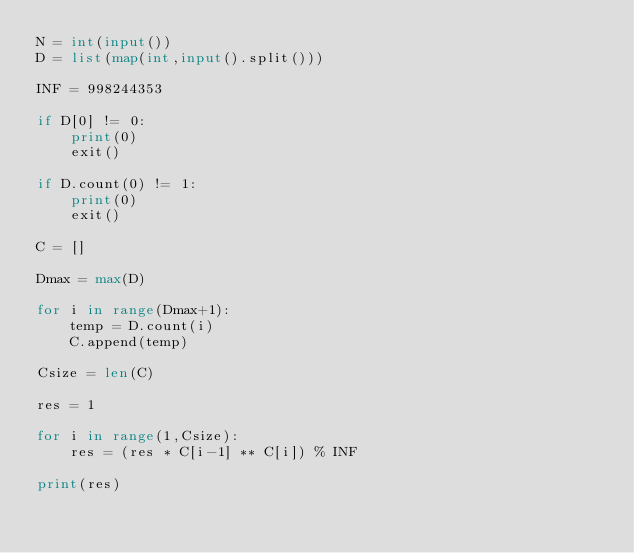<code> <loc_0><loc_0><loc_500><loc_500><_Python_>N = int(input())
D = list(map(int,input().split()))

INF = 998244353

if D[0] != 0:
    print(0)
    exit()

if D.count(0) != 1:
    print(0)
    exit()

C = []

Dmax = max(D)

for i in range(Dmax+1):
    temp = D.count(i)
    C.append(temp)

Csize = len(C)

res = 1

for i in range(1,Csize):
    res = (res * C[i-1] ** C[i]) % INF

print(res)
</code> 